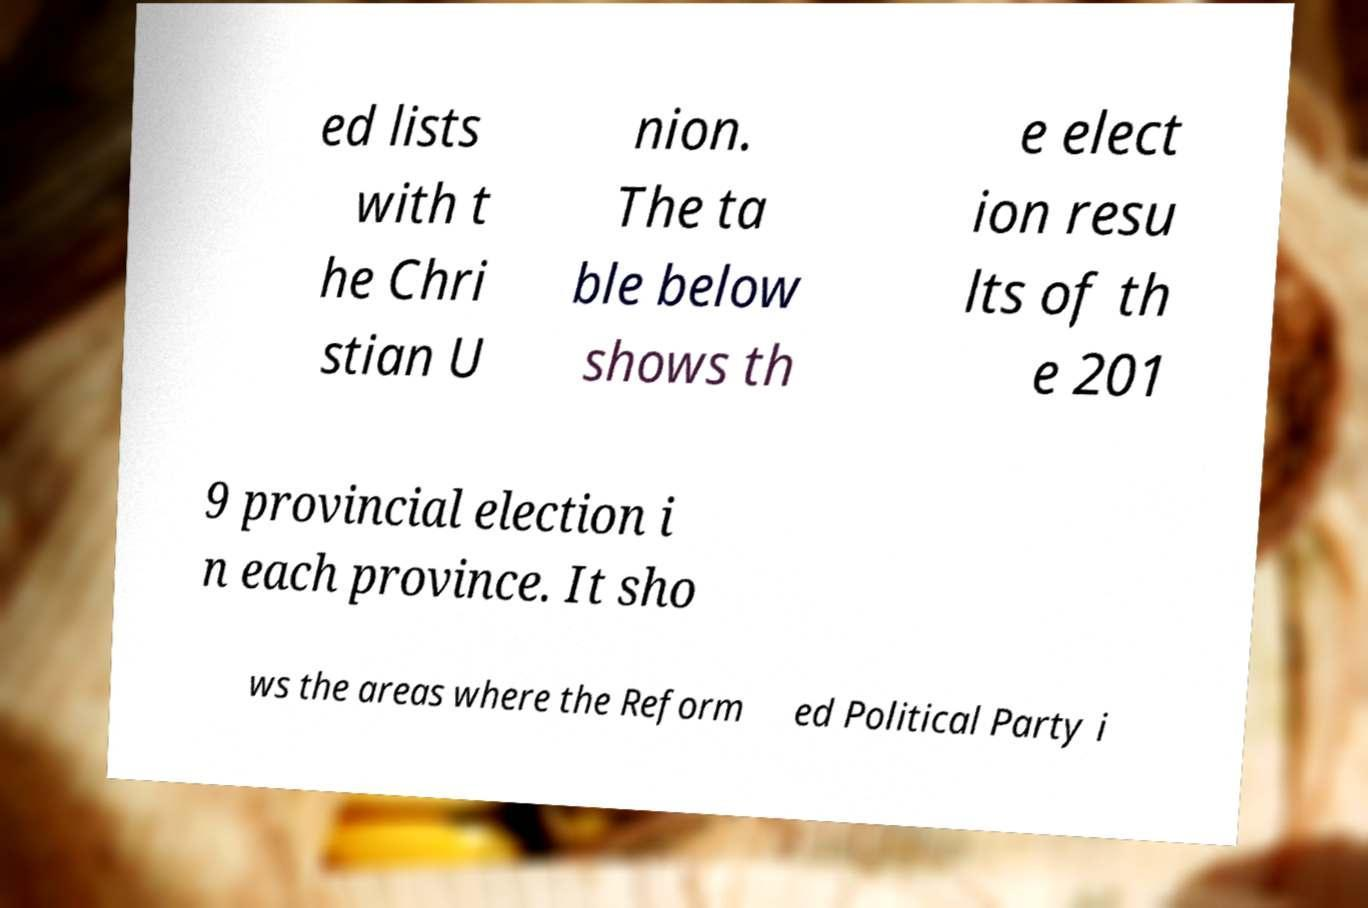Could you extract and type out the text from this image? ed lists with t he Chri stian U nion. The ta ble below shows th e elect ion resu lts of th e 201 9 provincial election i n each province. It sho ws the areas where the Reform ed Political Party i 